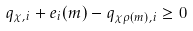Convert formula to latex. <formula><loc_0><loc_0><loc_500><loc_500>q _ { \chi , i } + e _ { i } ( m ) - q _ { \chi \rho ( m ) , i } \geq 0</formula> 